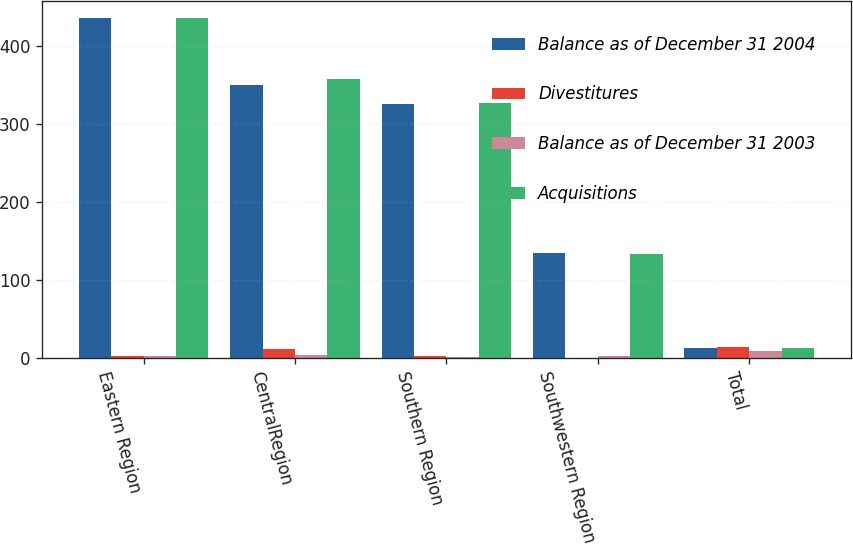Convert chart. <chart><loc_0><loc_0><loc_500><loc_500><stacked_bar_chart><ecel><fcel>Eastern Region<fcel>CentralRegion<fcel>Southern Region<fcel>Southwestern Region<fcel>Total<nl><fcel>Balance as of December 31 2004<fcel>435.9<fcel>350.5<fcel>325.8<fcel>135<fcel>11.95<nl><fcel>Divestitures<fcel>2.6<fcel>10.7<fcel>2<fcel>0.2<fcel>13.2<nl><fcel>Balance as of December 31 2003<fcel>2.1<fcel>3.6<fcel>1.3<fcel>1.6<fcel>8.6<nl><fcel>Acquisitions<fcel>436.4<fcel>357.6<fcel>326.5<fcel>133.6<fcel>11.95<nl></chart> 